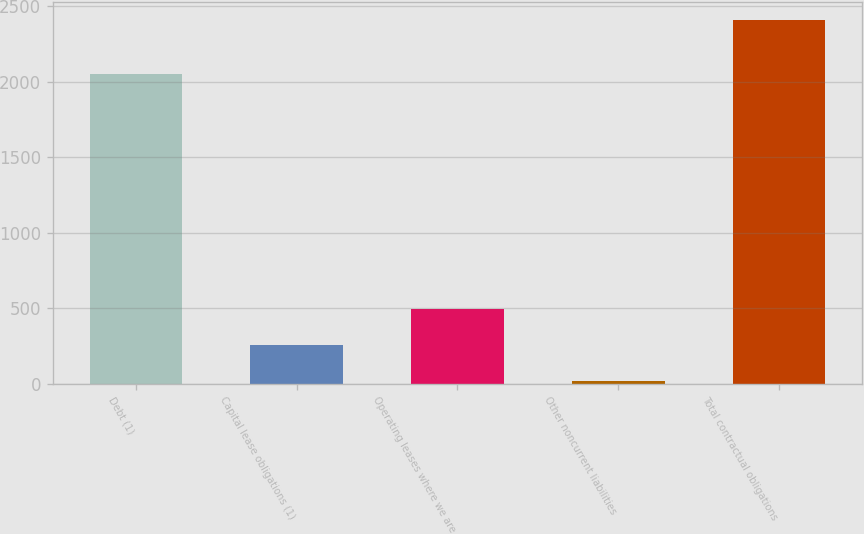Convert chart. <chart><loc_0><loc_0><loc_500><loc_500><bar_chart><fcel>Debt (1)<fcel>Capital lease obligations (1)<fcel>Operating leases where we are<fcel>Other noncurrent liabilities<fcel>Total contractual obligations<nl><fcel>2054<fcel>258.9<fcel>497.8<fcel>20<fcel>2409<nl></chart> 